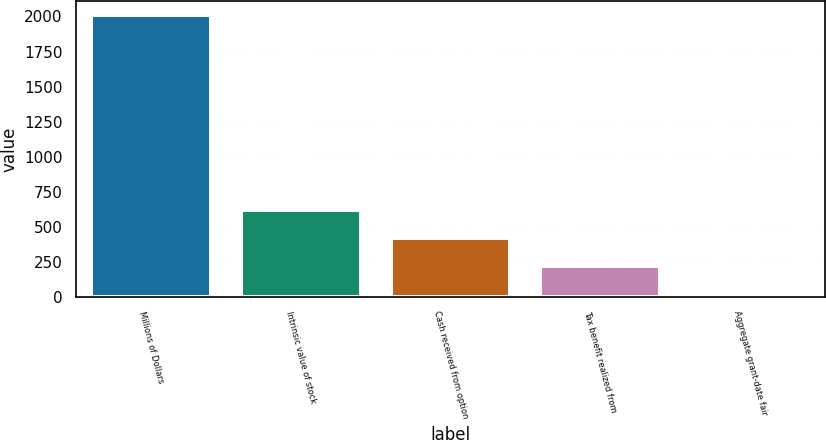<chart> <loc_0><loc_0><loc_500><loc_500><bar_chart><fcel>Millions of Dollars<fcel>Intrinsic value of stock<fcel>Cash received from option<fcel>Tax benefit realized from<fcel>Aggregate grant-date fair<nl><fcel>2008<fcel>617.1<fcel>418.4<fcel>219.7<fcel>21<nl></chart> 